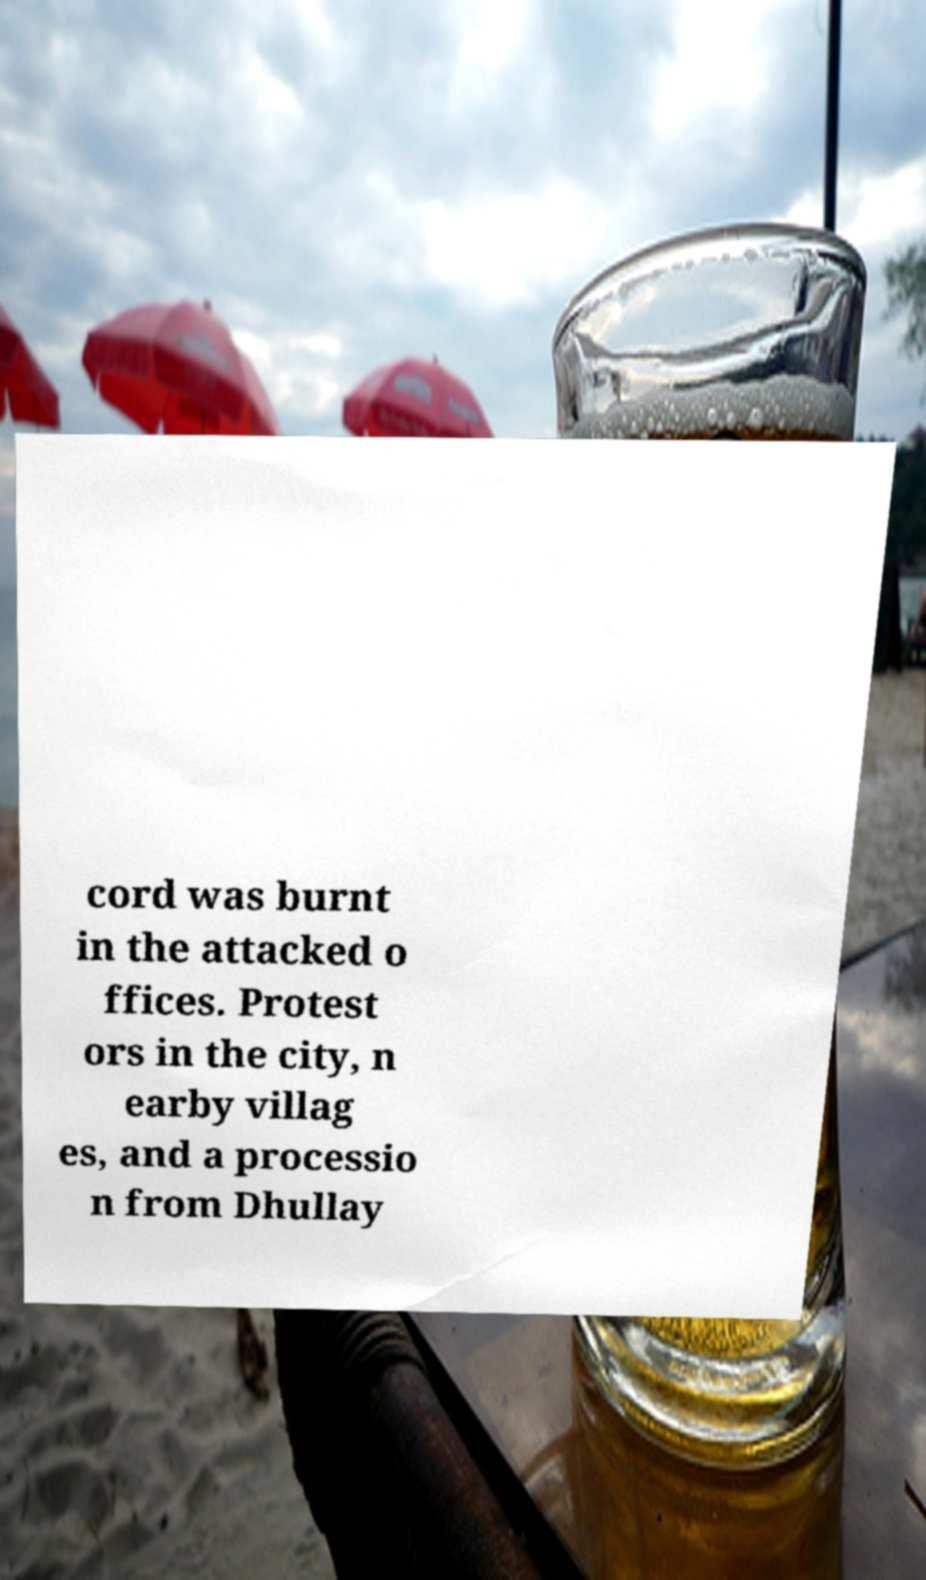What messages or text are displayed in this image? I need them in a readable, typed format. cord was burnt in the attacked o ffices. Protest ors in the city, n earby villag es, and a processio n from Dhullay 